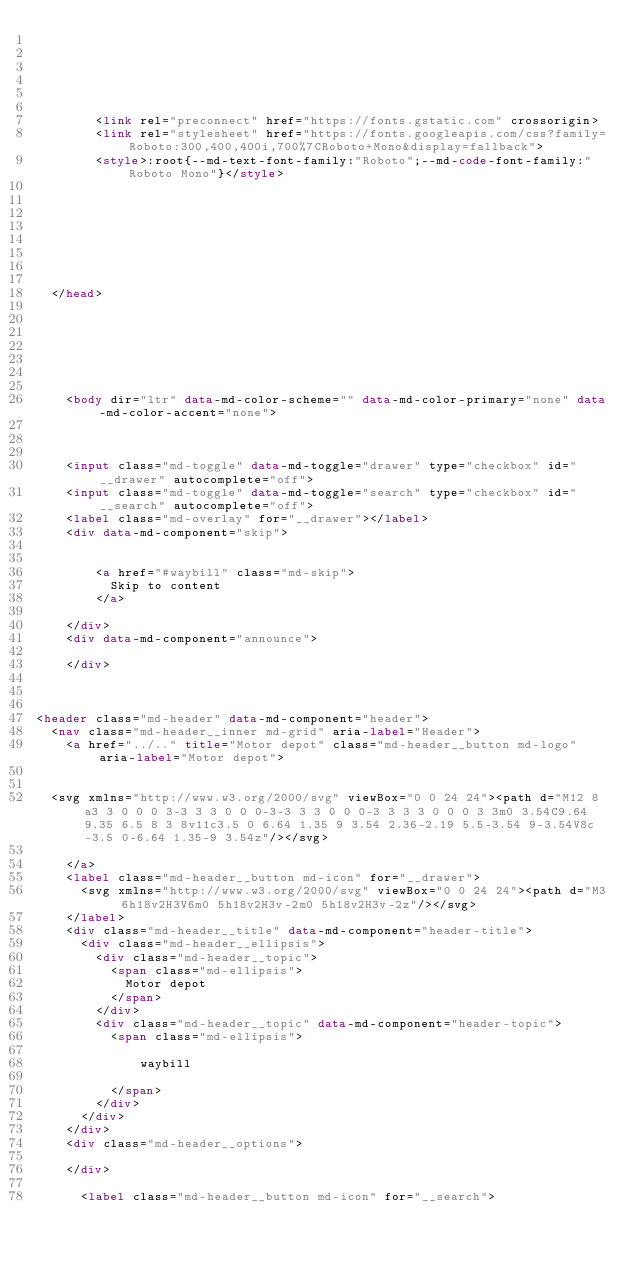Convert code to text. <code><loc_0><loc_0><loc_500><loc_500><_HTML_>      
    
    
    
      
        
        <link rel="preconnect" href="https://fonts.gstatic.com" crossorigin>
        <link rel="stylesheet" href="https://fonts.googleapis.com/css?family=Roboto:300,400,400i,700%7CRoboto+Mono&display=fallback">
        <style>:root{--md-text-font-family:"Roboto";--md-code-font-family:"Roboto Mono"}</style>
      
    
    
    
    
      
    
    
  </head>
  
  
    
    
    
    
    
    <body dir="ltr" data-md-color-scheme="" data-md-color-primary="none" data-md-color-accent="none">
      
  
    
    <input class="md-toggle" data-md-toggle="drawer" type="checkbox" id="__drawer" autocomplete="off">
    <input class="md-toggle" data-md-toggle="search" type="checkbox" id="__search" autocomplete="off">
    <label class="md-overlay" for="__drawer"></label>
    <div data-md-component="skip">
      
        
        <a href="#waybill" class="md-skip">
          Skip to content
        </a>
      
    </div>
    <div data-md-component="announce">
      
    </div>
    
      

<header class="md-header" data-md-component="header">
  <nav class="md-header__inner md-grid" aria-label="Header">
    <a href="../.." title="Motor depot" class="md-header__button md-logo" aria-label="Motor depot">
      
  
  <svg xmlns="http://www.w3.org/2000/svg" viewBox="0 0 24 24"><path d="M12 8a3 3 0 0 0 3-3 3 3 0 0 0-3-3 3 3 0 0 0-3 3 3 3 0 0 0 3 3m0 3.54C9.64 9.35 6.5 8 3 8v11c3.5 0 6.64 1.35 9 3.54 2.36-2.19 5.5-3.54 9-3.54V8c-3.5 0-6.64 1.35-9 3.54z"/></svg>

    </a>
    <label class="md-header__button md-icon" for="__drawer">
      <svg xmlns="http://www.w3.org/2000/svg" viewBox="0 0 24 24"><path d="M3 6h18v2H3V6m0 5h18v2H3v-2m0 5h18v2H3v-2z"/></svg>
    </label>
    <div class="md-header__title" data-md-component="header-title">
      <div class="md-header__ellipsis">
        <div class="md-header__topic">
          <span class="md-ellipsis">
            Motor depot
          </span>
        </div>
        <div class="md-header__topic" data-md-component="header-topic">
          <span class="md-ellipsis">
            
              waybill
            
          </span>
        </div>
      </div>
    </div>
    <div class="md-header__options">
      
    </div>
    
      <label class="md-header__button md-icon" for="__search"></code> 